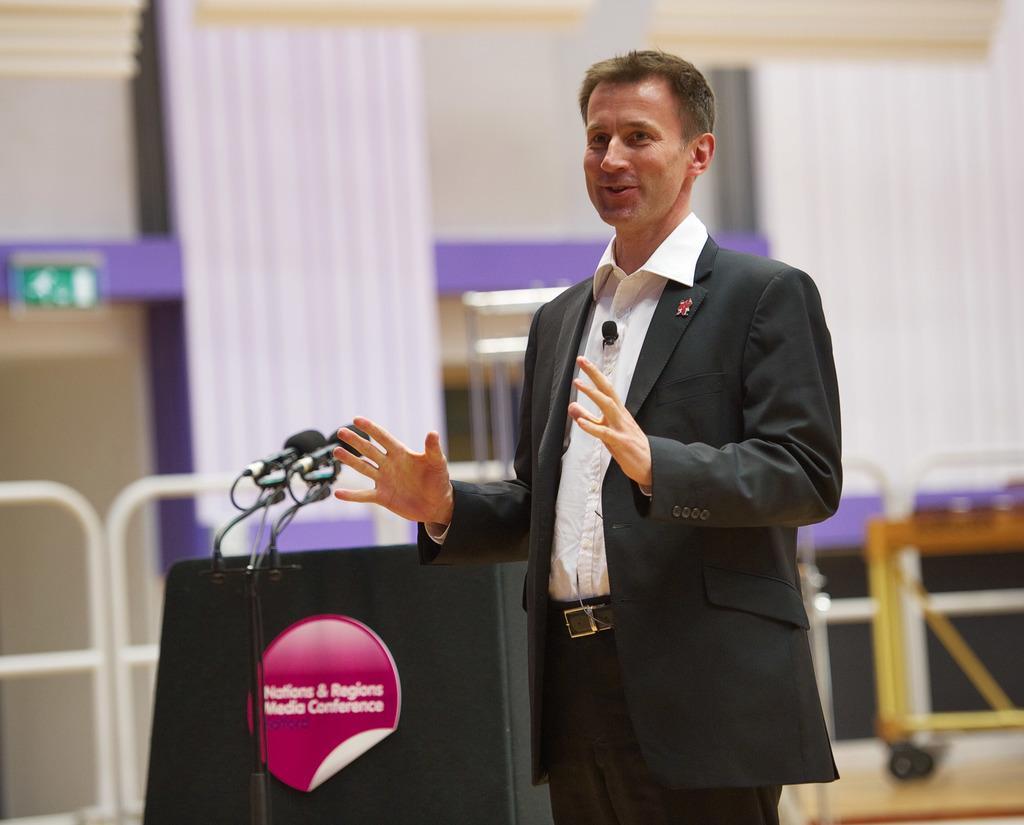Describe this image in one or two sentences. There is one man standing and wearing a black color blazer as we can see in the middle of this image. There is a Mic and a stand at the bottom of this image. There is a fence, curtain and a wall in the background. 